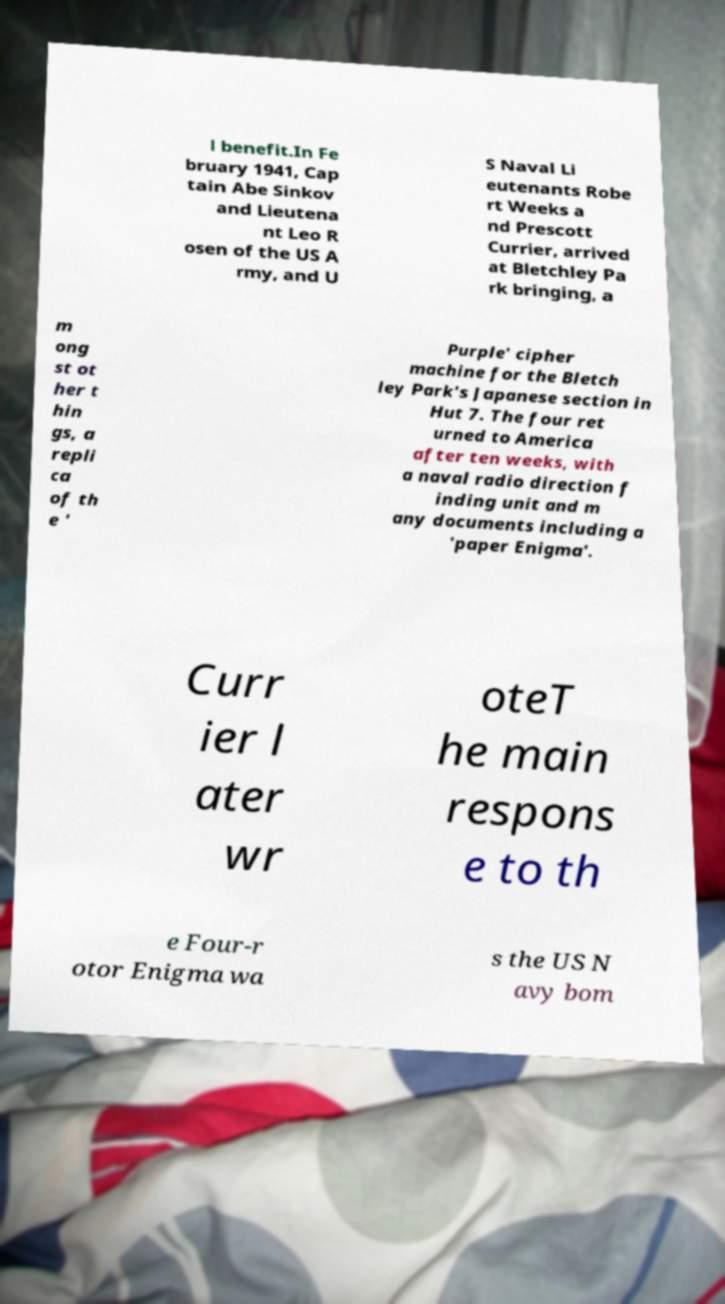Please read and relay the text visible in this image. What does it say? l benefit.In Fe bruary 1941, Cap tain Abe Sinkov and Lieutena nt Leo R osen of the US A rmy, and U S Naval Li eutenants Robe rt Weeks a nd Prescott Currier, arrived at Bletchley Pa rk bringing, a m ong st ot her t hin gs, a repli ca of th e ' Purple' cipher machine for the Bletch ley Park's Japanese section in Hut 7. The four ret urned to America after ten weeks, with a naval radio direction f inding unit and m any documents including a 'paper Enigma'. Curr ier l ater wr oteT he main respons e to th e Four-r otor Enigma wa s the US N avy bom 